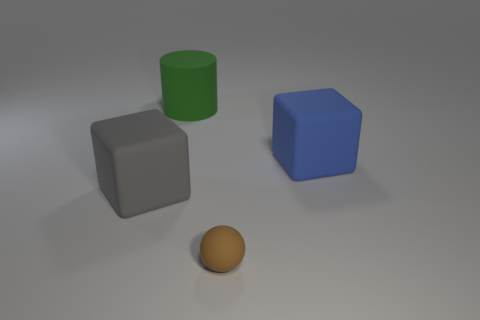Which objects in the image are capable of casting a shadow, and how would their shadows appear given the light source? All the objects in the image, including the brown matte ball, the gray block, and the green rubber cylinder, are capable of casting shadows based on the overhead light source. The shadows would appear opposite to the direction of the light, stretched out on the surface, with the shadow's size and sharpness varying depending on the object's height and distance from the light. 